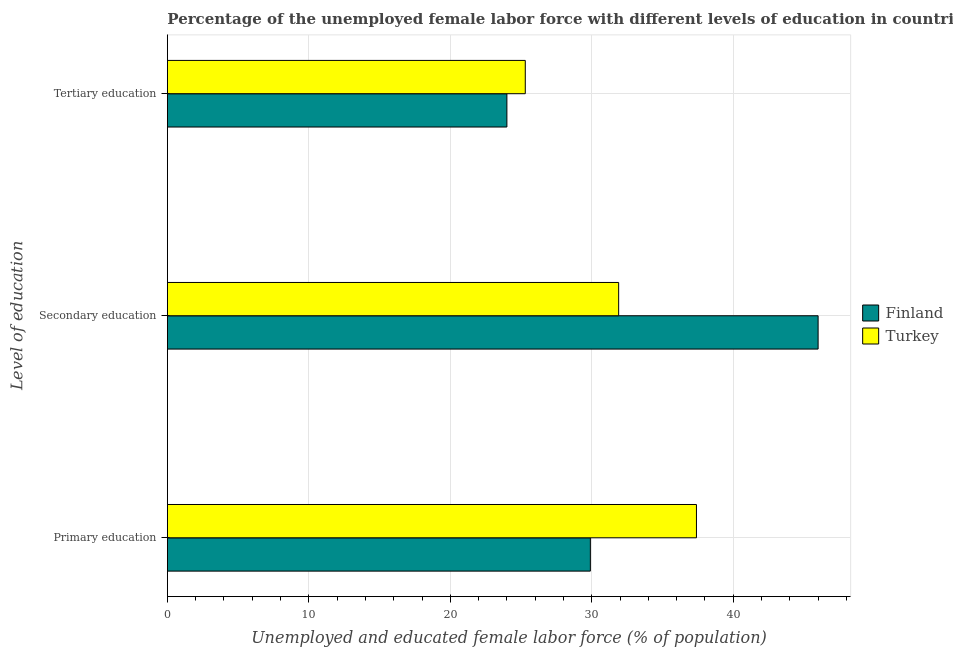How many different coloured bars are there?
Provide a short and direct response. 2. How many groups of bars are there?
Your response must be concise. 3. Are the number of bars per tick equal to the number of legend labels?
Your answer should be very brief. Yes. How many bars are there on the 3rd tick from the bottom?
Provide a short and direct response. 2. What is the label of the 3rd group of bars from the top?
Offer a very short reply. Primary education. What is the percentage of female labor force who received tertiary education in Turkey?
Your response must be concise. 25.3. Across all countries, what is the minimum percentage of female labor force who received secondary education?
Make the answer very short. 31.9. What is the total percentage of female labor force who received tertiary education in the graph?
Your response must be concise. 49.3. What is the difference between the percentage of female labor force who received secondary education in Turkey and that in Finland?
Offer a terse response. -14.1. What is the difference between the percentage of female labor force who received secondary education in Finland and the percentage of female labor force who received primary education in Turkey?
Your answer should be compact. 8.6. What is the average percentage of female labor force who received tertiary education per country?
Offer a terse response. 24.65. What is the difference between the percentage of female labor force who received primary education and percentage of female labor force who received tertiary education in Turkey?
Make the answer very short. 12.1. What is the ratio of the percentage of female labor force who received tertiary education in Turkey to that in Finland?
Provide a succinct answer. 1.05. Is the percentage of female labor force who received secondary education in Finland less than that in Turkey?
Offer a very short reply. No. What is the difference between the highest and the second highest percentage of female labor force who received tertiary education?
Provide a short and direct response. 1.3. What is the difference between the highest and the lowest percentage of female labor force who received tertiary education?
Make the answer very short. 1.3. In how many countries, is the percentage of female labor force who received secondary education greater than the average percentage of female labor force who received secondary education taken over all countries?
Provide a succinct answer. 1. Is the sum of the percentage of female labor force who received tertiary education in Turkey and Finland greater than the maximum percentage of female labor force who received primary education across all countries?
Provide a succinct answer. Yes. How many countries are there in the graph?
Your answer should be very brief. 2. What is the difference between two consecutive major ticks on the X-axis?
Give a very brief answer. 10. Are the values on the major ticks of X-axis written in scientific E-notation?
Provide a succinct answer. No. Does the graph contain any zero values?
Your answer should be very brief. No. Does the graph contain grids?
Provide a succinct answer. Yes. Where does the legend appear in the graph?
Your answer should be compact. Center right. What is the title of the graph?
Keep it short and to the point. Percentage of the unemployed female labor force with different levels of education in countries. What is the label or title of the X-axis?
Provide a succinct answer. Unemployed and educated female labor force (% of population). What is the label or title of the Y-axis?
Make the answer very short. Level of education. What is the Unemployed and educated female labor force (% of population) in Finland in Primary education?
Give a very brief answer. 29.9. What is the Unemployed and educated female labor force (% of population) in Turkey in Primary education?
Provide a short and direct response. 37.4. What is the Unemployed and educated female labor force (% of population) of Turkey in Secondary education?
Offer a very short reply. 31.9. What is the Unemployed and educated female labor force (% of population) in Turkey in Tertiary education?
Make the answer very short. 25.3. Across all Level of education, what is the maximum Unemployed and educated female labor force (% of population) in Finland?
Offer a very short reply. 46. Across all Level of education, what is the maximum Unemployed and educated female labor force (% of population) in Turkey?
Ensure brevity in your answer.  37.4. Across all Level of education, what is the minimum Unemployed and educated female labor force (% of population) of Turkey?
Provide a short and direct response. 25.3. What is the total Unemployed and educated female labor force (% of population) in Finland in the graph?
Give a very brief answer. 99.9. What is the total Unemployed and educated female labor force (% of population) of Turkey in the graph?
Your answer should be very brief. 94.6. What is the difference between the Unemployed and educated female labor force (% of population) in Finland in Primary education and that in Secondary education?
Provide a short and direct response. -16.1. What is the difference between the Unemployed and educated female labor force (% of population) in Turkey in Primary education and that in Secondary education?
Offer a very short reply. 5.5. What is the difference between the Unemployed and educated female labor force (% of population) in Finland in Primary education and that in Tertiary education?
Offer a terse response. 5.9. What is the difference between the Unemployed and educated female labor force (% of population) in Turkey in Secondary education and that in Tertiary education?
Provide a short and direct response. 6.6. What is the difference between the Unemployed and educated female labor force (% of population) of Finland in Secondary education and the Unemployed and educated female labor force (% of population) of Turkey in Tertiary education?
Offer a very short reply. 20.7. What is the average Unemployed and educated female labor force (% of population) of Finland per Level of education?
Offer a very short reply. 33.3. What is the average Unemployed and educated female labor force (% of population) of Turkey per Level of education?
Ensure brevity in your answer.  31.53. What is the ratio of the Unemployed and educated female labor force (% of population) in Finland in Primary education to that in Secondary education?
Offer a terse response. 0.65. What is the ratio of the Unemployed and educated female labor force (% of population) of Turkey in Primary education to that in Secondary education?
Your answer should be compact. 1.17. What is the ratio of the Unemployed and educated female labor force (% of population) of Finland in Primary education to that in Tertiary education?
Offer a very short reply. 1.25. What is the ratio of the Unemployed and educated female labor force (% of population) of Turkey in Primary education to that in Tertiary education?
Keep it short and to the point. 1.48. What is the ratio of the Unemployed and educated female labor force (% of population) in Finland in Secondary education to that in Tertiary education?
Ensure brevity in your answer.  1.92. What is the ratio of the Unemployed and educated female labor force (% of population) in Turkey in Secondary education to that in Tertiary education?
Keep it short and to the point. 1.26. What is the difference between the highest and the lowest Unemployed and educated female labor force (% of population) of Finland?
Offer a very short reply. 22. 